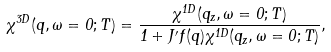<formula> <loc_0><loc_0><loc_500><loc_500>\chi ^ { 3 D } ( { q } , \omega = 0 ; T ) = \frac { \chi ^ { 1 D } ( q _ { z } , \omega = 0 ; T ) } { 1 + J ^ { \prime } f ( { q } ) \chi ^ { 1 D } ( q _ { z } , \omega = 0 ; T ) } ,</formula> 